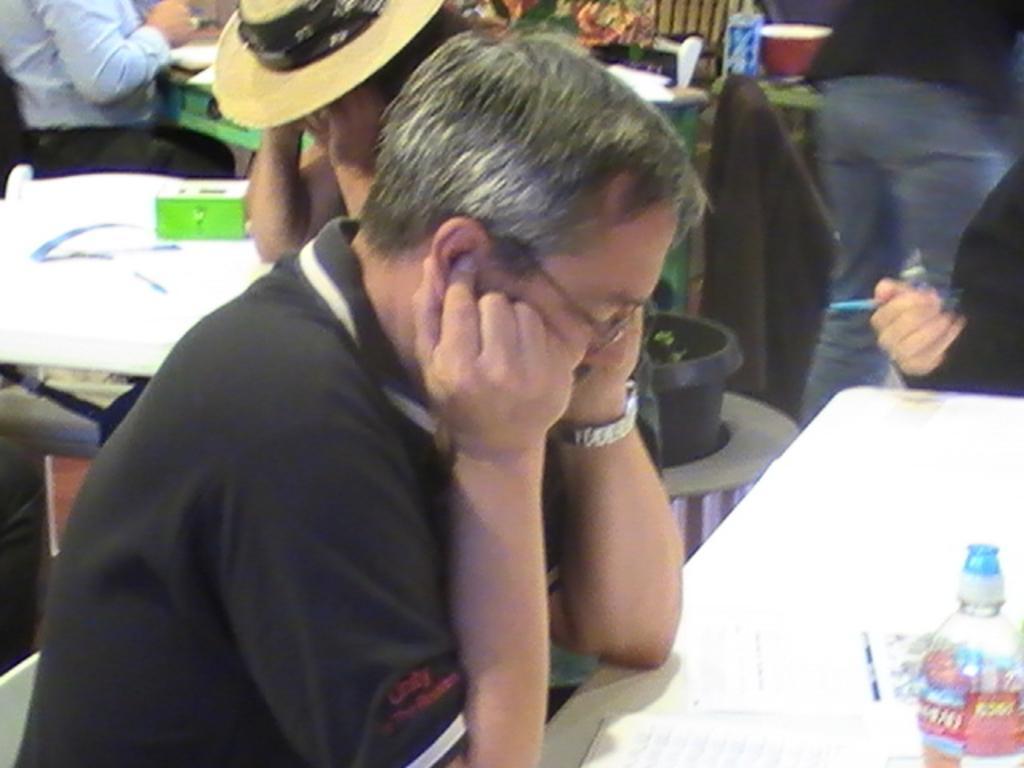Can you describe this image briefly? There is a person sitting and wearing specs and watch. In front of him there is a table. On the table there is a bottle and some papers. In the back there are many people. Also there is a pot with a plant. And a person wearing hat. Also there are tables in the back. 